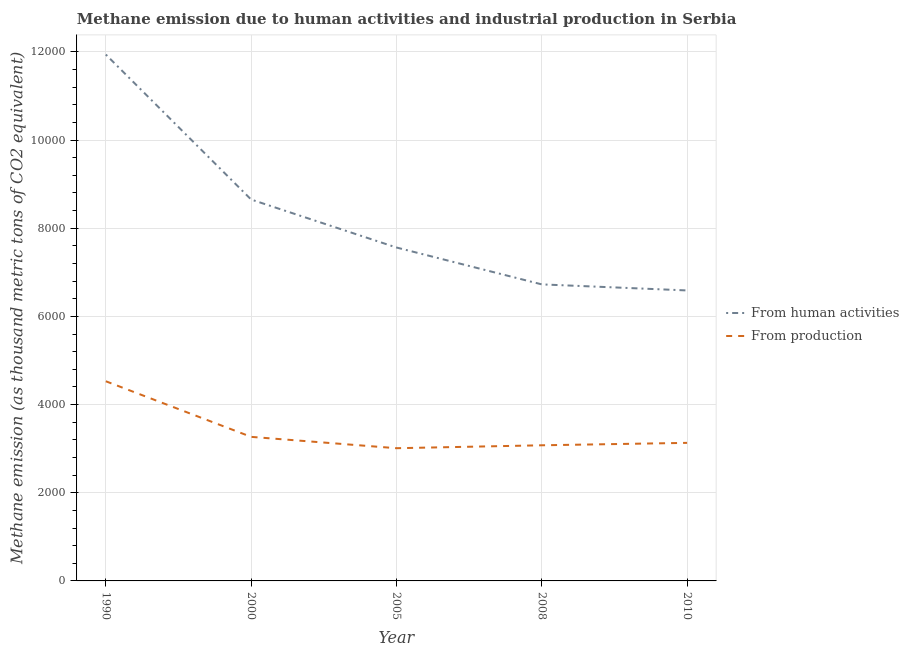How many different coloured lines are there?
Your answer should be compact. 2. Does the line corresponding to amount of emissions from human activities intersect with the line corresponding to amount of emissions generated from industries?
Your answer should be compact. No. Is the number of lines equal to the number of legend labels?
Your response must be concise. Yes. What is the amount of emissions from human activities in 2005?
Keep it short and to the point. 7563. Across all years, what is the maximum amount of emissions generated from industries?
Your answer should be very brief. 4529.1. Across all years, what is the minimum amount of emissions from human activities?
Give a very brief answer. 6589. What is the total amount of emissions generated from industries in the graph?
Offer a very short reply. 1.70e+04. What is the difference between the amount of emissions generated from industries in 1990 and that in 2008?
Ensure brevity in your answer.  1452.5. What is the difference between the amount of emissions generated from industries in 2010 and the amount of emissions from human activities in 2008?
Ensure brevity in your answer.  -3594.7. What is the average amount of emissions generated from industries per year?
Offer a very short reply. 3403.1. In the year 2008, what is the difference between the amount of emissions generated from industries and amount of emissions from human activities?
Give a very brief answer. -3649.8. What is the ratio of the amount of emissions generated from industries in 1990 to that in 2010?
Offer a very short reply. 1.45. Is the difference between the amount of emissions generated from industries in 2005 and 2008 greater than the difference between the amount of emissions from human activities in 2005 and 2008?
Offer a very short reply. No. What is the difference between the highest and the second highest amount of emissions from human activities?
Offer a terse response. 3288.8. What is the difference between the highest and the lowest amount of emissions from human activities?
Keep it short and to the point. 5350.7. Is the sum of the amount of emissions from human activities in 2008 and 2010 greater than the maximum amount of emissions generated from industries across all years?
Make the answer very short. Yes. What is the difference between two consecutive major ticks on the Y-axis?
Make the answer very short. 2000. Are the values on the major ticks of Y-axis written in scientific E-notation?
Give a very brief answer. No. Does the graph contain any zero values?
Your answer should be very brief. No. Where does the legend appear in the graph?
Keep it short and to the point. Center right. How many legend labels are there?
Your response must be concise. 2. How are the legend labels stacked?
Offer a terse response. Vertical. What is the title of the graph?
Give a very brief answer. Methane emission due to human activities and industrial production in Serbia. Does "Total Population" appear as one of the legend labels in the graph?
Make the answer very short. No. What is the label or title of the X-axis?
Your response must be concise. Year. What is the label or title of the Y-axis?
Make the answer very short. Methane emission (as thousand metric tons of CO2 equivalent). What is the Methane emission (as thousand metric tons of CO2 equivalent) of From human activities in 1990?
Ensure brevity in your answer.  1.19e+04. What is the Methane emission (as thousand metric tons of CO2 equivalent) in From production in 1990?
Offer a very short reply. 4529.1. What is the Methane emission (as thousand metric tons of CO2 equivalent) in From human activities in 2000?
Your answer should be compact. 8650.9. What is the Methane emission (as thousand metric tons of CO2 equivalent) of From production in 2000?
Make the answer very short. 3267.7. What is the Methane emission (as thousand metric tons of CO2 equivalent) of From human activities in 2005?
Your response must be concise. 7563. What is the Methane emission (as thousand metric tons of CO2 equivalent) in From production in 2005?
Your response must be concise. 3010.4. What is the Methane emission (as thousand metric tons of CO2 equivalent) of From human activities in 2008?
Give a very brief answer. 6726.4. What is the Methane emission (as thousand metric tons of CO2 equivalent) in From production in 2008?
Keep it short and to the point. 3076.6. What is the Methane emission (as thousand metric tons of CO2 equivalent) in From human activities in 2010?
Make the answer very short. 6589. What is the Methane emission (as thousand metric tons of CO2 equivalent) in From production in 2010?
Your answer should be very brief. 3131.7. Across all years, what is the maximum Methane emission (as thousand metric tons of CO2 equivalent) in From human activities?
Your response must be concise. 1.19e+04. Across all years, what is the maximum Methane emission (as thousand metric tons of CO2 equivalent) of From production?
Give a very brief answer. 4529.1. Across all years, what is the minimum Methane emission (as thousand metric tons of CO2 equivalent) in From human activities?
Provide a short and direct response. 6589. Across all years, what is the minimum Methane emission (as thousand metric tons of CO2 equivalent) in From production?
Make the answer very short. 3010.4. What is the total Methane emission (as thousand metric tons of CO2 equivalent) of From human activities in the graph?
Give a very brief answer. 4.15e+04. What is the total Methane emission (as thousand metric tons of CO2 equivalent) of From production in the graph?
Your answer should be very brief. 1.70e+04. What is the difference between the Methane emission (as thousand metric tons of CO2 equivalent) of From human activities in 1990 and that in 2000?
Make the answer very short. 3288.8. What is the difference between the Methane emission (as thousand metric tons of CO2 equivalent) of From production in 1990 and that in 2000?
Offer a terse response. 1261.4. What is the difference between the Methane emission (as thousand metric tons of CO2 equivalent) of From human activities in 1990 and that in 2005?
Offer a very short reply. 4376.7. What is the difference between the Methane emission (as thousand metric tons of CO2 equivalent) of From production in 1990 and that in 2005?
Your answer should be compact. 1518.7. What is the difference between the Methane emission (as thousand metric tons of CO2 equivalent) of From human activities in 1990 and that in 2008?
Keep it short and to the point. 5213.3. What is the difference between the Methane emission (as thousand metric tons of CO2 equivalent) of From production in 1990 and that in 2008?
Keep it short and to the point. 1452.5. What is the difference between the Methane emission (as thousand metric tons of CO2 equivalent) in From human activities in 1990 and that in 2010?
Make the answer very short. 5350.7. What is the difference between the Methane emission (as thousand metric tons of CO2 equivalent) of From production in 1990 and that in 2010?
Make the answer very short. 1397.4. What is the difference between the Methane emission (as thousand metric tons of CO2 equivalent) of From human activities in 2000 and that in 2005?
Make the answer very short. 1087.9. What is the difference between the Methane emission (as thousand metric tons of CO2 equivalent) in From production in 2000 and that in 2005?
Offer a terse response. 257.3. What is the difference between the Methane emission (as thousand metric tons of CO2 equivalent) of From human activities in 2000 and that in 2008?
Your response must be concise. 1924.5. What is the difference between the Methane emission (as thousand metric tons of CO2 equivalent) of From production in 2000 and that in 2008?
Give a very brief answer. 191.1. What is the difference between the Methane emission (as thousand metric tons of CO2 equivalent) of From human activities in 2000 and that in 2010?
Ensure brevity in your answer.  2061.9. What is the difference between the Methane emission (as thousand metric tons of CO2 equivalent) in From production in 2000 and that in 2010?
Provide a short and direct response. 136. What is the difference between the Methane emission (as thousand metric tons of CO2 equivalent) in From human activities in 2005 and that in 2008?
Offer a very short reply. 836.6. What is the difference between the Methane emission (as thousand metric tons of CO2 equivalent) in From production in 2005 and that in 2008?
Your answer should be compact. -66.2. What is the difference between the Methane emission (as thousand metric tons of CO2 equivalent) in From human activities in 2005 and that in 2010?
Provide a succinct answer. 974. What is the difference between the Methane emission (as thousand metric tons of CO2 equivalent) in From production in 2005 and that in 2010?
Make the answer very short. -121.3. What is the difference between the Methane emission (as thousand metric tons of CO2 equivalent) of From human activities in 2008 and that in 2010?
Offer a terse response. 137.4. What is the difference between the Methane emission (as thousand metric tons of CO2 equivalent) of From production in 2008 and that in 2010?
Offer a very short reply. -55.1. What is the difference between the Methane emission (as thousand metric tons of CO2 equivalent) in From human activities in 1990 and the Methane emission (as thousand metric tons of CO2 equivalent) in From production in 2000?
Offer a terse response. 8672. What is the difference between the Methane emission (as thousand metric tons of CO2 equivalent) of From human activities in 1990 and the Methane emission (as thousand metric tons of CO2 equivalent) of From production in 2005?
Provide a short and direct response. 8929.3. What is the difference between the Methane emission (as thousand metric tons of CO2 equivalent) of From human activities in 1990 and the Methane emission (as thousand metric tons of CO2 equivalent) of From production in 2008?
Provide a short and direct response. 8863.1. What is the difference between the Methane emission (as thousand metric tons of CO2 equivalent) of From human activities in 1990 and the Methane emission (as thousand metric tons of CO2 equivalent) of From production in 2010?
Offer a terse response. 8808. What is the difference between the Methane emission (as thousand metric tons of CO2 equivalent) of From human activities in 2000 and the Methane emission (as thousand metric tons of CO2 equivalent) of From production in 2005?
Provide a short and direct response. 5640.5. What is the difference between the Methane emission (as thousand metric tons of CO2 equivalent) of From human activities in 2000 and the Methane emission (as thousand metric tons of CO2 equivalent) of From production in 2008?
Provide a succinct answer. 5574.3. What is the difference between the Methane emission (as thousand metric tons of CO2 equivalent) in From human activities in 2000 and the Methane emission (as thousand metric tons of CO2 equivalent) in From production in 2010?
Your answer should be very brief. 5519.2. What is the difference between the Methane emission (as thousand metric tons of CO2 equivalent) in From human activities in 2005 and the Methane emission (as thousand metric tons of CO2 equivalent) in From production in 2008?
Your response must be concise. 4486.4. What is the difference between the Methane emission (as thousand metric tons of CO2 equivalent) of From human activities in 2005 and the Methane emission (as thousand metric tons of CO2 equivalent) of From production in 2010?
Offer a very short reply. 4431.3. What is the difference between the Methane emission (as thousand metric tons of CO2 equivalent) of From human activities in 2008 and the Methane emission (as thousand metric tons of CO2 equivalent) of From production in 2010?
Ensure brevity in your answer.  3594.7. What is the average Methane emission (as thousand metric tons of CO2 equivalent) in From human activities per year?
Offer a very short reply. 8293.8. What is the average Methane emission (as thousand metric tons of CO2 equivalent) of From production per year?
Make the answer very short. 3403.1. In the year 1990, what is the difference between the Methane emission (as thousand metric tons of CO2 equivalent) in From human activities and Methane emission (as thousand metric tons of CO2 equivalent) in From production?
Make the answer very short. 7410.6. In the year 2000, what is the difference between the Methane emission (as thousand metric tons of CO2 equivalent) in From human activities and Methane emission (as thousand metric tons of CO2 equivalent) in From production?
Keep it short and to the point. 5383.2. In the year 2005, what is the difference between the Methane emission (as thousand metric tons of CO2 equivalent) of From human activities and Methane emission (as thousand metric tons of CO2 equivalent) of From production?
Provide a short and direct response. 4552.6. In the year 2008, what is the difference between the Methane emission (as thousand metric tons of CO2 equivalent) of From human activities and Methane emission (as thousand metric tons of CO2 equivalent) of From production?
Ensure brevity in your answer.  3649.8. In the year 2010, what is the difference between the Methane emission (as thousand metric tons of CO2 equivalent) of From human activities and Methane emission (as thousand metric tons of CO2 equivalent) of From production?
Your answer should be compact. 3457.3. What is the ratio of the Methane emission (as thousand metric tons of CO2 equivalent) of From human activities in 1990 to that in 2000?
Ensure brevity in your answer.  1.38. What is the ratio of the Methane emission (as thousand metric tons of CO2 equivalent) of From production in 1990 to that in 2000?
Offer a very short reply. 1.39. What is the ratio of the Methane emission (as thousand metric tons of CO2 equivalent) of From human activities in 1990 to that in 2005?
Provide a succinct answer. 1.58. What is the ratio of the Methane emission (as thousand metric tons of CO2 equivalent) in From production in 1990 to that in 2005?
Your answer should be very brief. 1.5. What is the ratio of the Methane emission (as thousand metric tons of CO2 equivalent) in From human activities in 1990 to that in 2008?
Make the answer very short. 1.78. What is the ratio of the Methane emission (as thousand metric tons of CO2 equivalent) of From production in 1990 to that in 2008?
Provide a succinct answer. 1.47. What is the ratio of the Methane emission (as thousand metric tons of CO2 equivalent) of From human activities in 1990 to that in 2010?
Ensure brevity in your answer.  1.81. What is the ratio of the Methane emission (as thousand metric tons of CO2 equivalent) of From production in 1990 to that in 2010?
Your answer should be compact. 1.45. What is the ratio of the Methane emission (as thousand metric tons of CO2 equivalent) of From human activities in 2000 to that in 2005?
Ensure brevity in your answer.  1.14. What is the ratio of the Methane emission (as thousand metric tons of CO2 equivalent) in From production in 2000 to that in 2005?
Provide a succinct answer. 1.09. What is the ratio of the Methane emission (as thousand metric tons of CO2 equivalent) of From human activities in 2000 to that in 2008?
Your answer should be compact. 1.29. What is the ratio of the Methane emission (as thousand metric tons of CO2 equivalent) in From production in 2000 to that in 2008?
Your response must be concise. 1.06. What is the ratio of the Methane emission (as thousand metric tons of CO2 equivalent) in From human activities in 2000 to that in 2010?
Make the answer very short. 1.31. What is the ratio of the Methane emission (as thousand metric tons of CO2 equivalent) in From production in 2000 to that in 2010?
Your response must be concise. 1.04. What is the ratio of the Methane emission (as thousand metric tons of CO2 equivalent) in From human activities in 2005 to that in 2008?
Your answer should be very brief. 1.12. What is the ratio of the Methane emission (as thousand metric tons of CO2 equivalent) of From production in 2005 to that in 2008?
Your answer should be very brief. 0.98. What is the ratio of the Methane emission (as thousand metric tons of CO2 equivalent) of From human activities in 2005 to that in 2010?
Your response must be concise. 1.15. What is the ratio of the Methane emission (as thousand metric tons of CO2 equivalent) in From production in 2005 to that in 2010?
Your answer should be very brief. 0.96. What is the ratio of the Methane emission (as thousand metric tons of CO2 equivalent) in From human activities in 2008 to that in 2010?
Your response must be concise. 1.02. What is the ratio of the Methane emission (as thousand metric tons of CO2 equivalent) of From production in 2008 to that in 2010?
Offer a very short reply. 0.98. What is the difference between the highest and the second highest Methane emission (as thousand metric tons of CO2 equivalent) of From human activities?
Give a very brief answer. 3288.8. What is the difference between the highest and the second highest Methane emission (as thousand metric tons of CO2 equivalent) in From production?
Provide a short and direct response. 1261.4. What is the difference between the highest and the lowest Methane emission (as thousand metric tons of CO2 equivalent) of From human activities?
Keep it short and to the point. 5350.7. What is the difference between the highest and the lowest Methane emission (as thousand metric tons of CO2 equivalent) in From production?
Provide a short and direct response. 1518.7. 